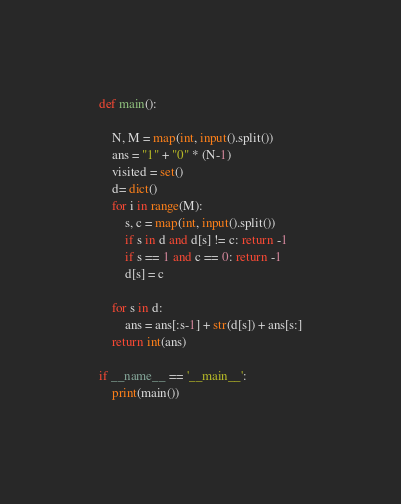<code> <loc_0><loc_0><loc_500><loc_500><_Python_>def main():

    N, M = map(int, input().split())
    ans = "1" + "0" * (N-1)
    visited = set()
    d= dict()
    for i in range(M):
        s, c = map(int, input().split())
        if s in d and d[s] != c: return -1
        if s == 1 and c == 0: return -1
        d[s] = c

    for s in d:
        ans = ans[:s-1] + str(d[s]) + ans[s:]
    return int(ans)

if __name__ == '__main__':
    print(main())
</code> 